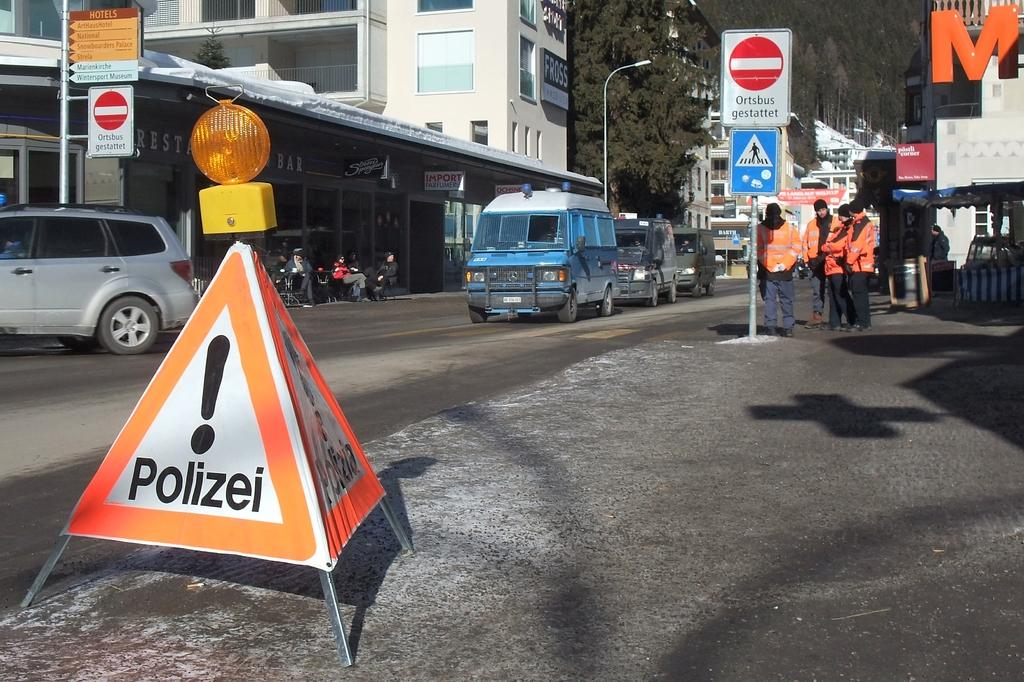<image>
Give a short and clear explanation of the subsequent image. a polizei label that is on an item 